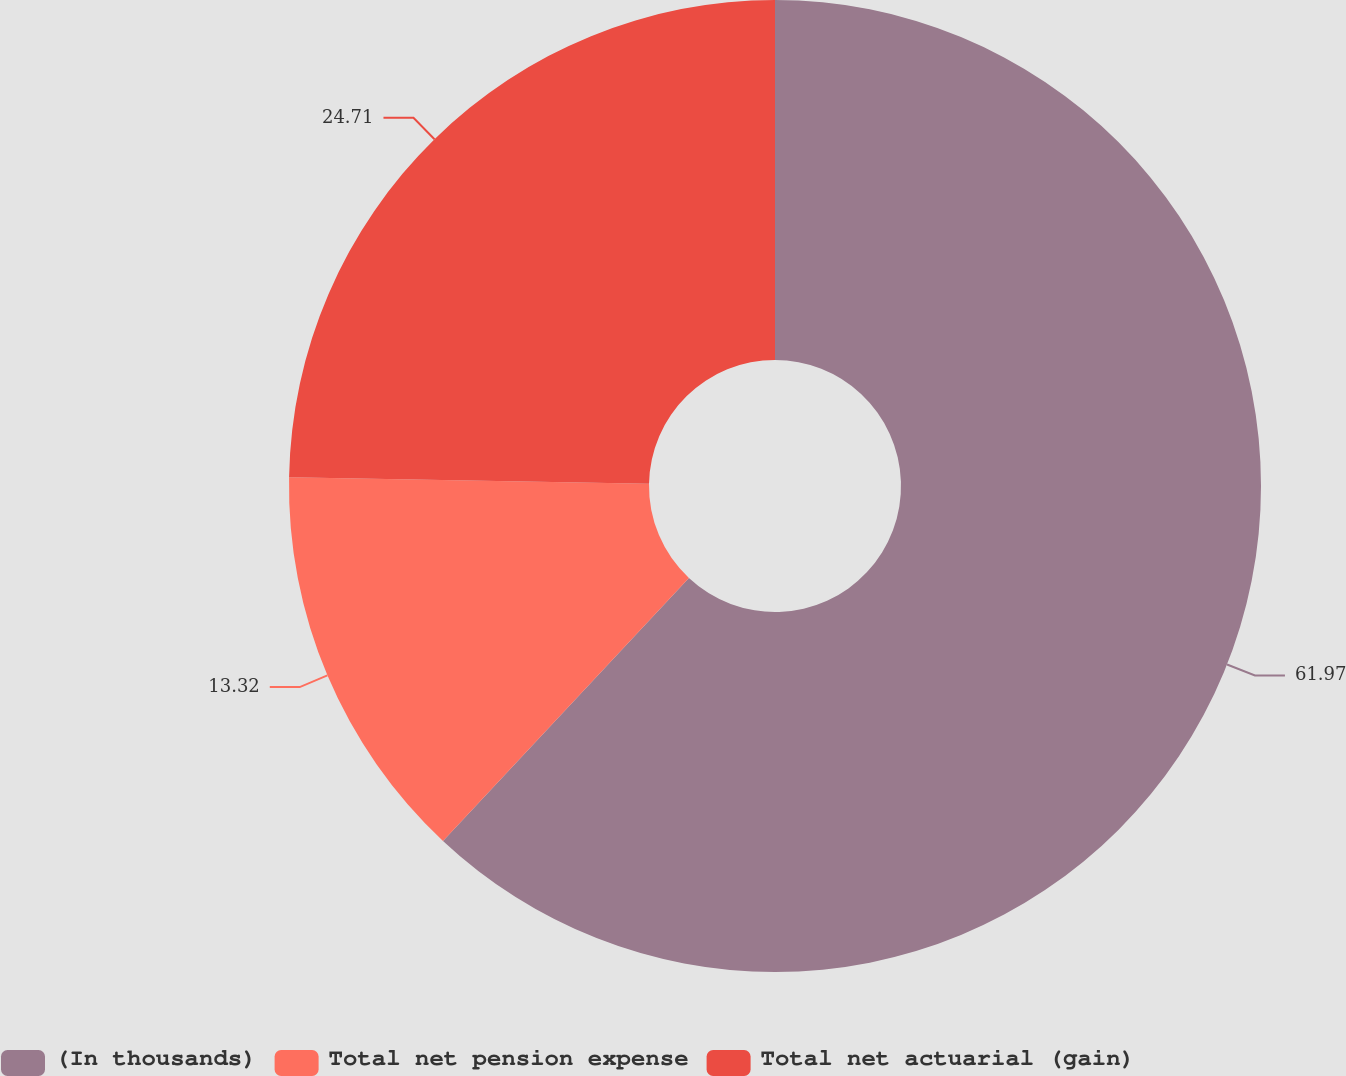Convert chart. <chart><loc_0><loc_0><loc_500><loc_500><pie_chart><fcel>(In thousands)<fcel>Total net pension expense<fcel>Total net actuarial (gain)<nl><fcel>61.97%<fcel>13.32%<fcel>24.71%<nl></chart> 